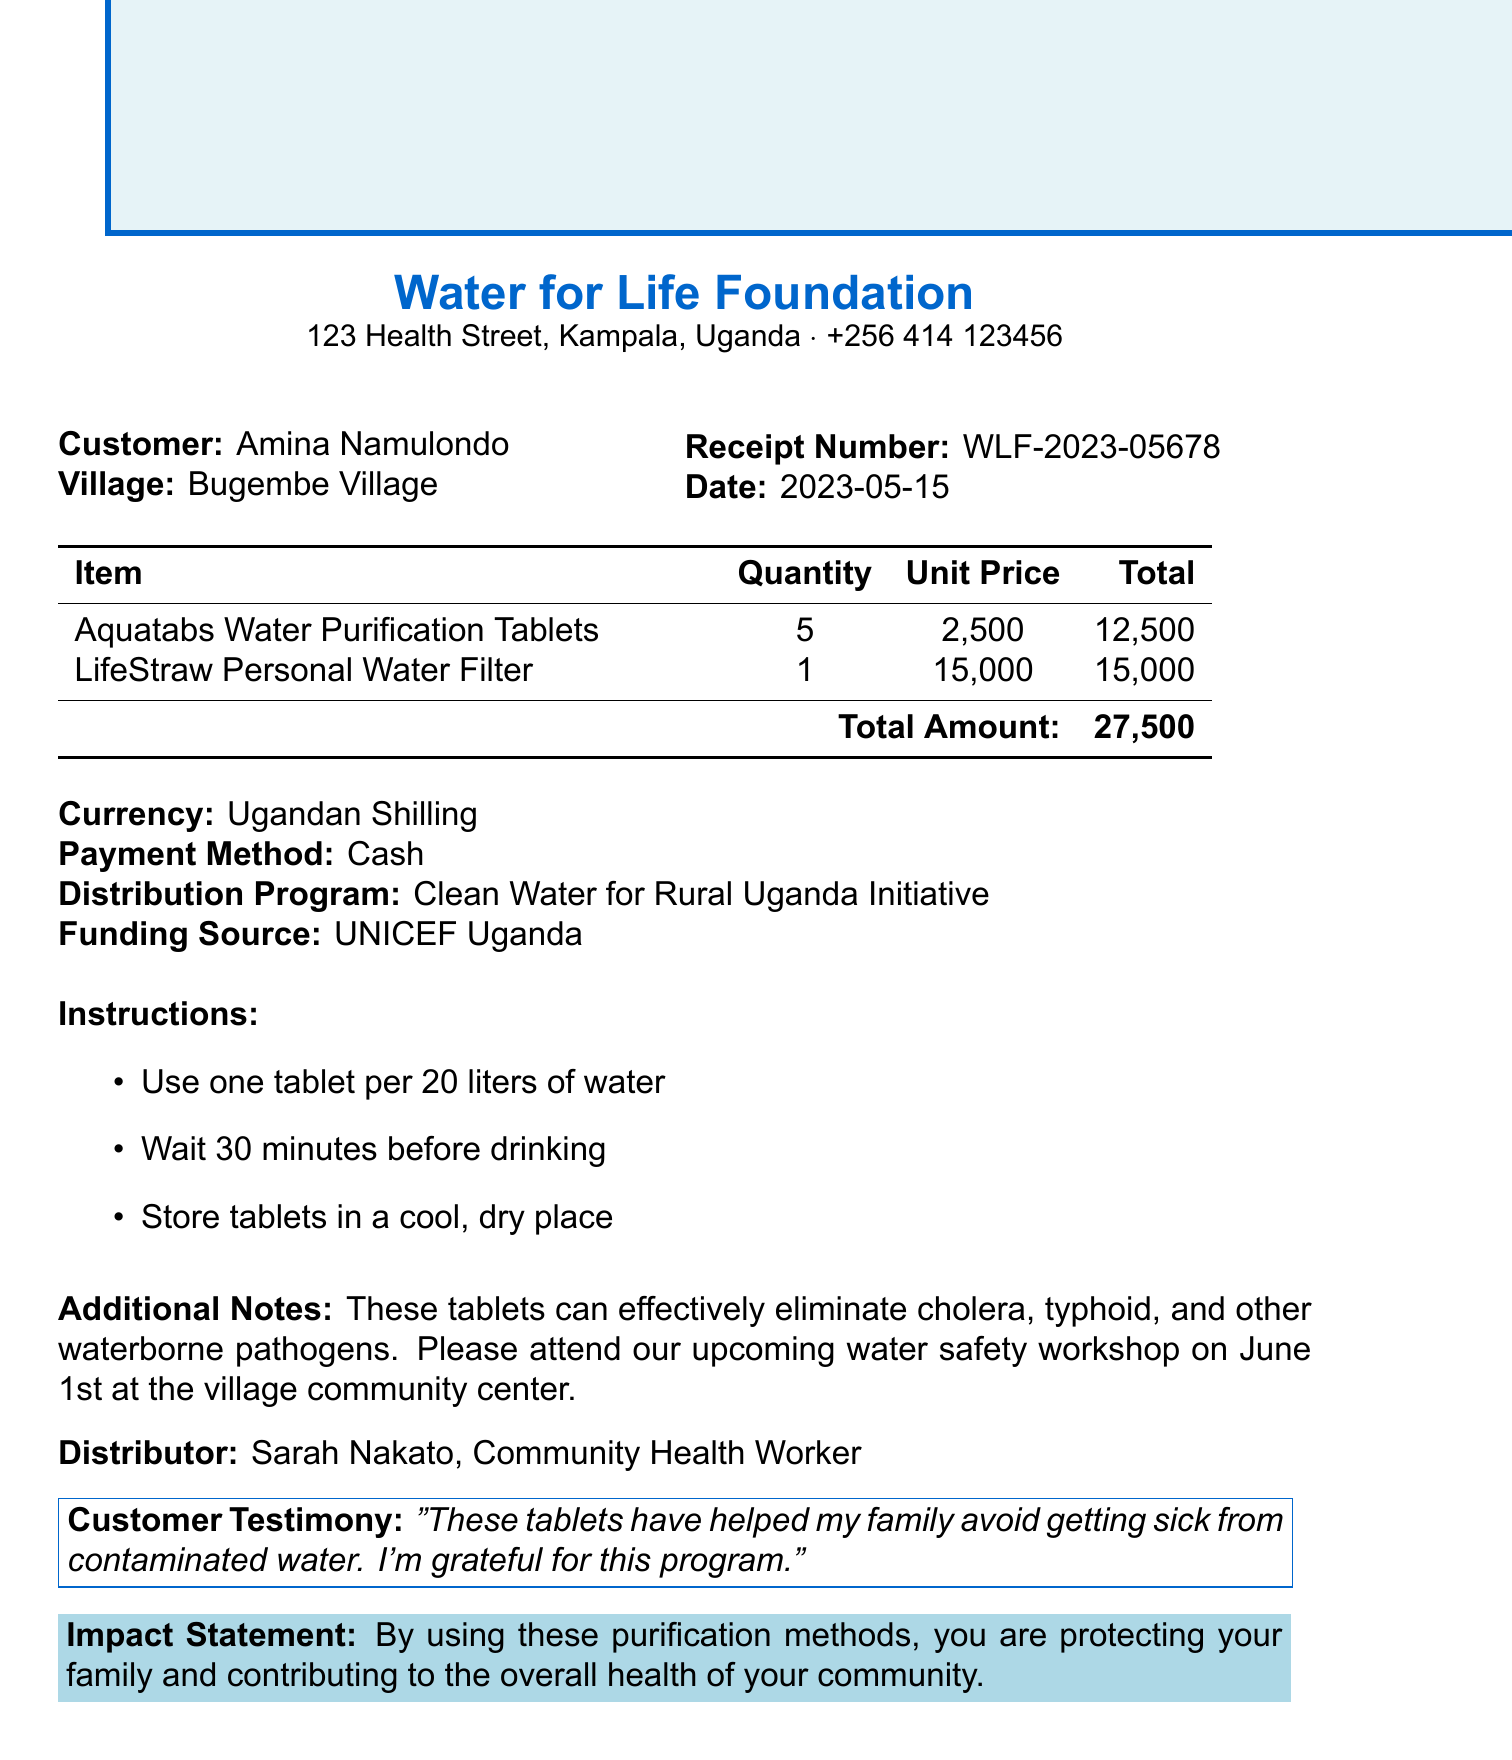What is the name of the organization? The organization that issued the receipt is named "Water for Life Foundation."
Answer: Water for Life Foundation What is the total amount paid? The total amount listed on the receipt is the sum of the prices of all items purchased.
Answer: 27,500 What is the customer’s village? The village indicated for the customer on the receipt is where she lives.
Answer: Bugembe Village When was the receipt issued? The date on the receipt states when the transaction occurred.
Answer: 2023-05-15 What product did Amina purchase in addition to the water purification tablets? The other item listed on the receipt shows what else was bought along with the tablets.
Answer: LifeStraw Personal Water Filter What instructions are given for the water purification tablets? The instructions provide guidance on how to properly use the purchased product.
Answer: Use one tablet per 20 liters of water Who is the distributor mentioned in the document? The document mentions a specific person who distributed or sold the water purification tablets.
Answer: Sarah Nakato What impact statement is provided? The impact statement summarizes the benefit of using the products purchased from the foundation.
Answer: By using these purification methods, you are protecting your family and contributing to the overall health of your community 